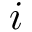Convert formula to latex. <formula><loc_0><loc_0><loc_500><loc_500>i</formula> 